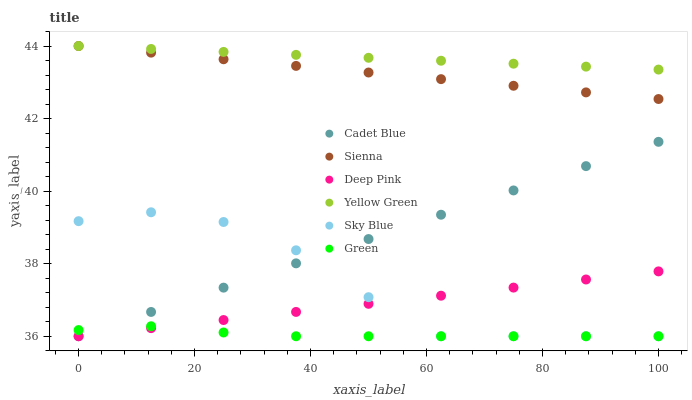Does Green have the minimum area under the curve?
Answer yes or no. Yes. Does Yellow Green have the maximum area under the curve?
Answer yes or no. Yes. Does Sienna have the minimum area under the curve?
Answer yes or no. No. Does Sienna have the maximum area under the curve?
Answer yes or no. No. Is Yellow Green the smoothest?
Answer yes or no. Yes. Is Sky Blue the roughest?
Answer yes or no. Yes. Is Sienna the smoothest?
Answer yes or no. No. Is Sienna the roughest?
Answer yes or no. No. Does Cadet Blue have the lowest value?
Answer yes or no. Yes. Does Sienna have the lowest value?
Answer yes or no. No. Does Sienna have the highest value?
Answer yes or no. Yes. Does Deep Pink have the highest value?
Answer yes or no. No. Is Deep Pink less than Sienna?
Answer yes or no. Yes. Is Sienna greater than Cadet Blue?
Answer yes or no. Yes. Does Green intersect Sky Blue?
Answer yes or no. Yes. Is Green less than Sky Blue?
Answer yes or no. No. Is Green greater than Sky Blue?
Answer yes or no. No. Does Deep Pink intersect Sienna?
Answer yes or no. No. 